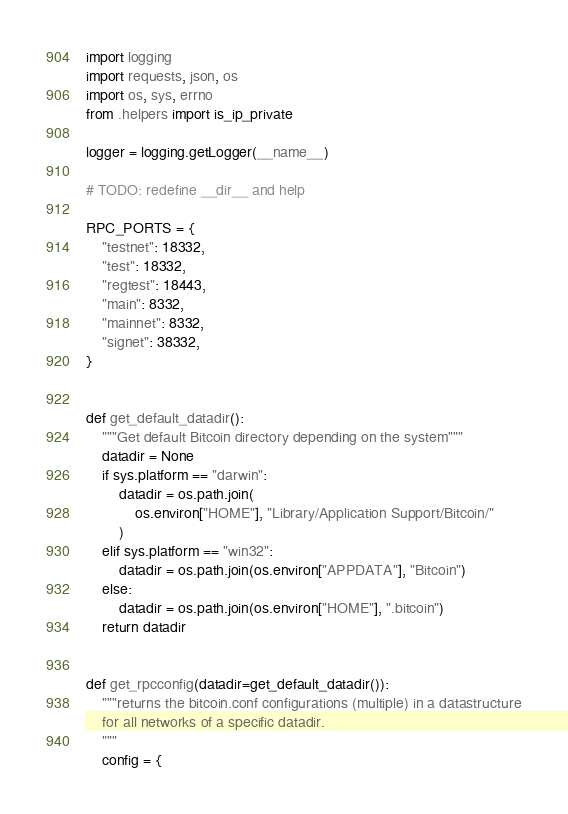Convert code to text. <code><loc_0><loc_0><loc_500><loc_500><_Python_>import logging
import requests, json, os
import os, sys, errno
from .helpers import is_ip_private

logger = logging.getLogger(__name__)

# TODO: redefine __dir__ and help

RPC_PORTS = {
    "testnet": 18332,
    "test": 18332,
    "regtest": 18443,
    "main": 8332,
    "mainnet": 8332,
    "signet": 38332,
}


def get_default_datadir():
    """Get default Bitcoin directory depending on the system"""
    datadir = None
    if sys.platform == "darwin":
        datadir = os.path.join(
            os.environ["HOME"], "Library/Application Support/Bitcoin/"
        )
    elif sys.platform == "win32":
        datadir = os.path.join(os.environ["APPDATA"], "Bitcoin")
    else:
        datadir = os.path.join(os.environ["HOME"], ".bitcoin")
    return datadir


def get_rpcconfig(datadir=get_default_datadir()):
    """returns the bitcoin.conf configurations (multiple) in a datastructure
    for all networks of a specific datadir.
    """
    config = {</code> 